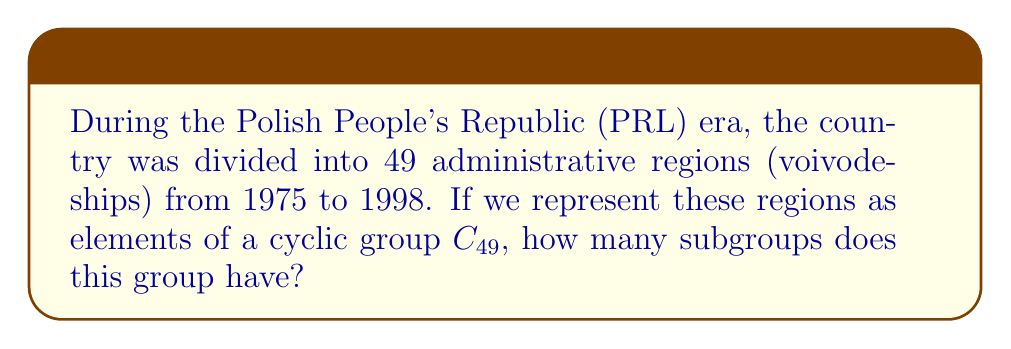Help me with this question. To solve this problem, we need to follow these steps:

1) First, recall that the number of subgroups in a cyclic group $C_n$ is equal to the number of divisors of $n$.

2) In this case, we need to find the divisors of 49.

3) To find the divisors of 49, let's factor it:
   $49 = 7^2$

4) The divisors of $49$ are:
   $1, 7,$ and $49$

5) Therefore, the cyclic group $C_{49}$ has 3 subgroups:
   - The trivial subgroup $\{e\}$ (corresponding to the divisor 1)
   - A subgroup of order 7 (corresponding to the divisor 7)
   - The entire group $C_{49}$ itself (corresponding to the divisor 49)

6) Each of these subgroups can be interpreted in the context of the administrative divisions:
   - The trivial subgroup represents no grouping of voivodeships
   - The subgroup of order 7 represents grouping the voivodeships into 7 larger regions
   - The entire group represents considering all 49 voivodeships individually

This mathematical model provides an interesting perspective on potential ways to organize or analyze the administrative divisions during the PRL era.
Answer: The cyclic group $C_{49}$, representing the 49 administrative regions of Poland during the PRL era from 1975 to 1998, has 3 subgroups. 